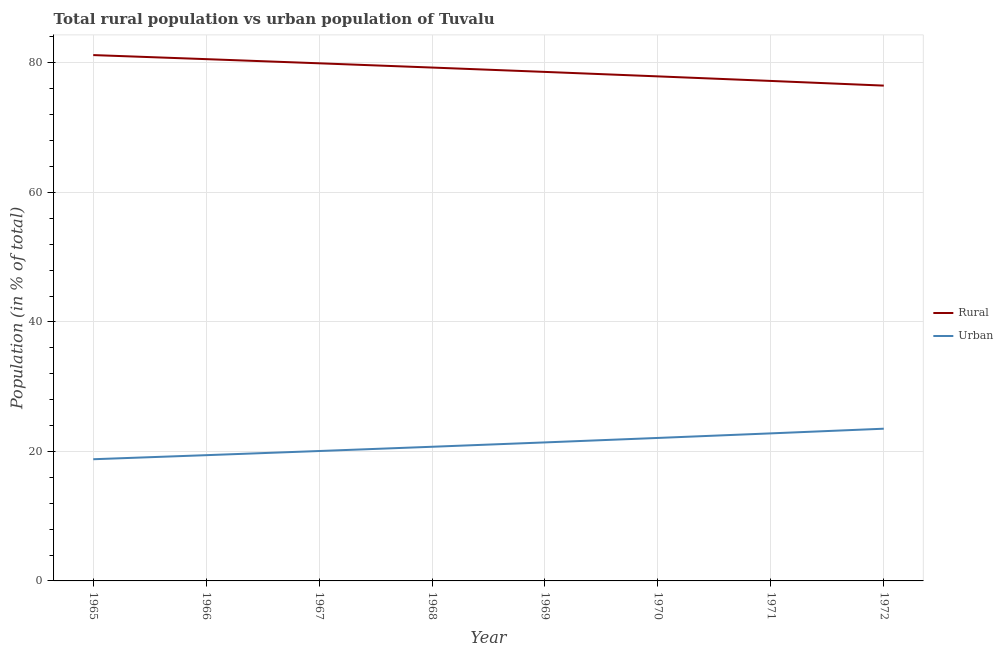What is the urban population in 1970?
Your response must be concise. 22.08. Across all years, what is the maximum urban population?
Ensure brevity in your answer.  23.51. Across all years, what is the minimum rural population?
Ensure brevity in your answer.  76.49. In which year was the rural population maximum?
Your answer should be very brief. 1965. In which year was the rural population minimum?
Ensure brevity in your answer.  1972. What is the total rural population in the graph?
Your answer should be compact. 631.24. What is the difference between the urban population in 1968 and that in 1971?
Your answer should be compact. -2.07. What is the difference between the urban population in 1965 and the rural population in 1968?
Offer a very short reply. -60.49. What is the average urban population per year?
Offer a very short reply. 21.09. In the year 1967, what is the difference between the urban population and rural population?
Give a very brief answer. -59.88. In how many years, is the rural population greater than 8 %?
Make the answer very short. 8. What is the ratio of the urban population in 1967 to that in 1969?
Ensure brevity in your answer.  0.94. Is the rural population in 1965 less than that in 1971?
Your answer should be very brief. No. What is the difference between the highest and the second highest rural population?
Offer a terse response. 0.63. What is the difference between the highest and the lowest urban population?
Give a very brief answer. 4.71. How many lines are there?
Offer a terse response. 2. What is the difference between two consecutive major ticks on the Y-axis?
Offer a very short reply. 20. Are the values on the major ticks of Y-axis written in scientific E-notation?
Your answer should be very brief. No. Does the graph contain grids?
Provide a short and direct response. Yes. Where does the legend appear in the graph?
Give a very brief answer. Center right. How are the legend labels stacked?
Keep it short and to the point. Vertical. What is the title of the graph?
Ensure brevity in your answer.  Total rural population vs urban population of Tuvalu. Does "Under-5(female)" appear as one of the legend labels in the graph?
Make the answer very short. No. What is the label or title of the X-axis?
Your response must be concise. Year. What is the label or title of the Y-axis?
Your answer should be very brief. Population (in % of total). What is the Population (in % of total) of Rural in 1965?
Make the answer very short. 81.21. What is the Population (in % of total) in Urban in 1965?
Ensure brevity in your answer.  18.79. What is the Population (in % of total) of Rural in 1966?
Your answer should be very brief. 80.58. What is the Population (in % of total) in Urban in 1966?
Your answer should be compact. 19.42. What is the Population (in % of total) of Rural in 1967?
Make the answer very short. 79.94. What is the Population (in % of total) in Urban in 1967?
Your answer should be very brief. 20.06. What is the Population (in % of total) in Rural in 1968?
Keep it short and to the point. 79.28. What is the Population (in % of total) in Urban in 1968?
Your response must be concise. 20.72. What is the Population (in % of total) in Rural in 1969?
Your answer should be compact. 78.61. What is the Population (in % of total) of Urban in 1969?
Keep it short and to the point. 21.39. What is the Population (in % of total) in Rural in 1970?
Offer a very short reply. 77.92. What is the Population (in % of total) in Urban in 1970?
Provide a succinct answer. 22.08. What is the Population (in % of total) of Rural in 1971?
Provide a succinct answer. 77.21. What is the Population (in % of total) of Urban in 1971?
Offer a very short reply. 22.79. What is the Population (in % of total) in Rural in 1972?
Make the answer very short. 76.49. What is the Population (in % of total) of Urban in 1972?
Provide a short and direct response. 23.51. Across all years, what is the maximum Population (in % of total) in Rural?
Offer a terse response. 81.21. Across all years, what is the maximum Population (in % of total) of Urban?
Your response must be concise. 23.51. Across all years, what is the minimum Population (in % of total) of Rural?
Give a very brief answer. 76.49. Across all years, what is the minimum Population (in % of total) in Urban?
Ensure brevity in your answer.  18.79. What is the total Population (in % of total) of Rural in the graph?
Make the answer very short. 631.24. What is the total Population (in % of total) in Urban in the graph?
Your answer should be compact. 168.76. What is the difference between the Population (in % of total) in Rural in 1965 and that in 1966?
Make the answer very short. 0.63. What is the difference between the Population (in % of total) of Urban in 1965 and that in 1966?
Keep it short and to the point. -0.63. What is the difference between the Population (in % of total) in Rural in 1965 and that in 1967?
Your answer should be compact. 1.27. What is the difference between the Population (in % of total) of Urban in 1965 and that in 1967?
Make the answer very short. -1.27. What is the difference between the Population (in % of total) in Rural in 1965 and that in 1968?
Provide a succinct answer. 1.93. What is the difference between the Population (in % of total) in Urban in 1965 and that in 1968?
Your answer should be very brief. -1.93. What is the difference between the Population (in % of total) of Rural in 1965 and that in 1969?
Provide a short and direct response. 2.6. What is the difference between the Population (in % of total) in Urban in 1965 and that in 1969?
Your answer should be compact. -2.6. What is the difference between the Population (in % of total) of Rural in 1965 and that in 1970?
Offer a very short reply. 3.29. What is the difference between the Population (in % of total) in Urban in 1965 and that in 1970?
Make the answer very short. -3.29. What is the difference between the Population (in % of total) of Rural in 1965 and that in 1971?
Your answer should be compact. 3.99. What is the difference between the Population (in % of total) in Urban in 1965 and that in 1971?
Offer a very short reply. -3.99. What is the difference between the Population (in % of total) in Rural in 1965 and that in 1972?
Offer a very short reply. 4.71. What is the difference between the Population (in % of total) in Urban in 1965 and that in 1972?
Your answer should be compact. -4.71. What is the difference between the Population (in % of total) of Rural in 1966 and that in 1967?
Your response must be concise. 0.64. What is the difference between the Population (in % of total) in Urban in 1966 and that in 1967?
Provide a succinct answer. -0.64. What is the difference between the Population (in % of total) of Rural in 1966 and that in 1968?
Your answer should be very brief. 1.3. What is the difference between the Population (in % of total) in Urban in 1966 and that in 1968?
Your response must be concise. -1.3. What is the difference between the Population (in % of total) of Rural in 1966 and that in 1969?
Make the answer very short. 1.97. What is the difference between the Population (in % of total) of Urban in 1966 and that in 1969?
Your answer should be compact. -1.97. What is the difference between the Population (in % of total) in Rural in 1966 and that in 1970?
Make the answer very short. 2.66. What is the difference between the Population (in % of total) of Urban in 1966 and that in 1970?
Your answer should be very brief. -2.66. What is the difference between the Population (in % of total) of Rural in 1966 and that in 1971?
Offer a terse response. 3.37. What is the difference between the Population (in % of total) in Urban in 1966 and that in 1971?
Ensure brevity in your answer.  -3.37. What is the difference between the Population (in % of total) in Rural in 1966 and that in 1972?
Offer a terse response. 4.09. What is the difference between the Population (in % of total) in Urban in 1966 and that in 1972?
Provide a short and direct response. -4.09. What is the difference between the Population (in % of total) in Rural in 1967 and that in 1968?
Your answer should be very brief. 0.66. What is the difference between the Population (in % of total) of Urban in 1967 and that in 1968?
Your response must be concise. -0.66. What is the difference between the Population (in % of total) of Rural in 1967 and that in 1969?
Keep it short and to the point. 1.33. What is the difference between the Population (in % of total) of Urban in 1967 and that in 1969?
Give a very brief answer. -1.33. What is the difference between the Population (in % of total) in Rural in 1967 and that in 1970?
Your response must be concise. 2.02. What is the difference between the Population (in % of total) in Urban in 1967 and that in 1970?
Provide a short and direct response. -2.02. What is the difference between the Population (in % of total) of Rural in 1967 and that in 1971?
Provide a short and direct response. 2.73. What is the difference between the Population (in % of total) of Urban in 1967 and that in 1971?
Your answer should be compact. -2.73. What is the difference between the Population (in % of total) of Rural in 1967 and that in 1972?
Offer a very short reply. 3.45. What is the difference between the Population (in % of total) in Urban in 1967 and that in 1972?
Make the answer very short. -3.45. What is the difference between the Population (in % of total) of Rural in 1968 and that in 1969?
Ensure brevity in your answer.  0.67. What is the difference between the Population (in % of total) in Urban in 1968 and that in 1969?
Provide a succinct answer. -0.67. What is the difference between the Population (in % of total) in Rural in 1968 and that in 1970?
Your response must be concise. 1.36. What is the difference between the Population (in % of total) in Urban in 1968 and that in 1970?
Offer a terse response. -1.36. What is the difference between the Population (in % of total) in Rural in 1968 and that in 1971?
Offer a very short reply. 2.07. What is the difference between the Population (in % of total) of Urban in 1968 and that in 1971?
Provide a short and direct response. -2.07. What is the difference between the Population (in % of total) of Rural in 1968 and that in 1972?
Your response must be concise. 2.79. What is the difference between the Population (in % of total) in Urban in 1968 and that in 1972?
Your response must be concise. -2.79. What is the difference between the Population (in % of total) of Rural in 1969 and that in 1970?
Give a very brief answer. 0.69. What is the difference between the Population (in % of total) in Urban in 1969 and that in 1970?
Give a very brief answer. -0.69. What is the difference between the Population (in % of total) in Rural in 1969 and that in 1971?
Your answer should be very brief. 1.39. What is the difference between the Population (in % of total) of Urban in 1969 and that in 1971?
Your answer should be compact. -1.39. What is the difference between the Population (in % of total) of Rural in 1969 and that in 1972?
Provide a short and direct response. 2.12. What is the difference between the Population (in % of total) of Urban in 1969 and that in 1972?
Ensure brevity in your answer.  -2.12. What is the difference between the Population (in % of total) in Rural in 1970 and that in 1971?
Provide a short and direct response. 0.7. What is the difference between the Population (in % of total) in Urban in 1970 and that in 1971?
Provide a succinct answer. -0.7. What is the difference between the Population (in % of total) in Rural in 1970 and that in 1972?
Keep it short and to the point. 1.43. What is the difference between the Population (in % of total) of Urban in 1970 and that in 1972?
Offer a very short reply. -1.43. What is the difference between the Population (in % of total) in Rural in 1971 and that in 1972?
Ensure brevity in your answer.  0.72. What is the difference between the Population (in % of total) of Urban in 1971 and that in 1972?
Keep it short and to the point. -0.72. What is the difference between the Population (in % of total) of Rural in 1965 and the Population (in % of total) of Urban in 1966?
Keep it short and to the point. 61.79. What is the difference between the Population (in % of total) in Rural in 1965 and the Population (in % of total) in Urban in 1967?
Your response must be concise. 61.15. What is the difference between the Population (in % of total) in Rural in 1965 and the Population (in % of total) in Urban in 1968?
Your answer should be compact. 60.49. What is the difference between the Population (in % of total) in Rural in 1965 and the Population (in % of total) in Urban in 1969?
Offer a very short reply. 59.81. What is the difference between the Population (in % of total) of Rural in 1965 and the Population (in % of total) of Urban in 1970?
Provide a succinct answer. 59.13. What is the difference between the Population (in % of total) of Rural in 1965 and the Population (in % of total) of Urban in 1971?
Your answer should be compact. 58.42. What is the difference between the Population (in % of total) of Rural in 1965 and the Population (in % of total) of Urban in 1972?
Your answer should be compact. 57.7. What is the difference between the Population (in % of total) in Rural in 1966 and the Population (in % of total) in Urban in 1967?
Your answer should be very brief. 60.52. What is the difference between the Population (in % of total) of Rural in 1966 and the Population (in % of total) of Urban in 1968?
Make the answer very short. 59.86. What is the difference between the Population (in % of total) in Rural in 1966 and the Population (in % of total) in Urban in 1969?
Your answer should be compact. 59.19. What is the difference between the Population (in % of total) in Rural in 1966 and the Population (in % of total) in Urban in 1970?
Give a very brief answer. 58.5. What is the difference between the Population (in % of total) of Rural in 1966 and the Population (in % of total) of Urban in 1971?
Ensure brevity in your answer.  57.8. What is the difference between the Population (in % of total) in Rural in 1966 and the Population (in % of total) in Urban in 1972?
Your answer should be compact. 57.07. What is the difference between the Population (in % of total) of Rural in 1967 and the Population (in % of total) of Urban in 1968?
Offer a very short reply. 59.22. What is the difference between the Population (in % of total) in Rural in 1967 and the Population (in % of total) in Urban in 1969?
Offer a terse response. 58.55. What is the difference between the Population (in % of total) of Rural in 1967 and the Population (in % of total) of Urban in 1970?
Offer a very short reply. 57.86. What is the difference between the Population (in % of total) in Rural in 1967 and the Population (in % of total) in Urban in 1971?
Your response must be concise. 57.15. What is the difference between the Population (in % of total) in Rural in 1967 and the Population (in % of total) in Urban in 1972?
Provide a short and direct response. 56.43. What is the difference between the Population (in % of total) in Rural in 1968 and the Population (in % of total) in Urban in 1969?
Your answer should be compact. 57.89. What is the difference between the Population (in % of total) in Rural in 1968 and the Population (in % of total) in Urban in 1970?
Make the answer very short. 57.2. What is the difference between the Population (in % of total) of Rural in 1968 and the Population (in % of total) of Urban in 1971?
Ensure brevity in your answer.  56.49. What is the difference between the Population (in % of total) in Rural in 1968 and the Population (in % of total) in Urban in 1972?
Offer a very short reply. 55.77. What is the difference between the Population (in % of total) in Rural in 1969 and the Population (in % of total) in Urban in 1970?
Provide a short and direct response. 56.53. What is the difference between the Population (in % of total) of Rural in 1969 and the Population (in % of total) of Urban in 1971?
Provide a succinct answer. 55.82. What is the difference between the Population (in % of total) of Rural in 1969 and the Population (in % of total) of Urban in 1972?
Your answer should be compact. 55.1. What is the difference between the Population (in % of total) of Rural in 1970 and the Population (in % of total) of Urban in 1971?
Provide a short and direct response. 55.13. What is the difference between the Population (in % of total) in Rural in 1970 and the Population (in % of total) in Urban in 1972?
Your answer should be very brief. 54.41. What is the difference between the Population (in % of total) in Rural in 1971 and the Population (in % of total) in Urban in 1972?
Offer a terse response. 53.71. What is the average Population (in % of total) of Rural per year?
Offer a very short reply. 78.91. What is the average Population (in % of total) in Urban per year?
Give a very brief answer. 21.09. In the year 1965, what is the difference between the Population (in % of total) of Rural and Population (in % of total) of Urban?
Offer a very short reply. 62.41. In the year 1966, what is the difference between the Population (in % of total) of Rural and Population (in % of total) of Urban?
Provide a succinct answer. 61.16. In the year 1967, what is the difference between the Population (in % of total) in Rural and Population (in % of total) in Urban?
Provide a short and direct response. 59.88. In the year 1968, what is the difference between the Population (in % of total) of Rural and Population (in % of total) of Urban?
Ensure brevity in your answer.  58.56. In the year 1969, what is the difference between the Population (in % of total) in Rural and Population (in % of total) in Urban?
Make the answer very short. 57.22. In the year 1970, what is the difference between the Population (in % of total) in Rural and Population (in % of total) in Urban?
Keep it short and to the point. 55.84. In the year 1971, what is the difference between the Population (in % of total) of Rural and Population (in % of total) of Urban?
Your response must be concise. 54.43. In the year 1972, what is the difference between the Population (in % of total) in Rural and Population (in % of total) in Urban?
Make the answer very short. 52.99. What is the ratio of the Population (in % of total) in Urban in 1965 to that in 1966?
Your response must be concise. 0.97. What is the ratio of the Population (in % of total) of Rural in 1965 to that in 1967?
Ensure brevity in your answer.  1.02. What is the ratio of the Population (in % of total) of Urban in 1965 to that in 1967?
Provide a short and direct response. 0.94. What is the ratio of the Population (in % of total) in Rural in 1965 to that in 1968?
Your answer should be very brief. 1.02. What is the ratio of the Population (in % of total) in Urban in 1965 to that in 1968?
Keep it short and to the point. 0.91. What is the ratio of the Population (in % of total) in Rural in 1965 to that in 1969?
Provide a short and direct response. 1.03. What is the ratio of the Population (in % of total) of Urban in 1965 to that in 1969?
Ensure brevity in your answer.  0.88. What is the ratio of the Population (in % of total) in Rural in 1965 to that in 1970?
Make the answer very short. 1.04. What is the ratio of the Population (in % of total) in Urban in 1965 to that in 1970?
Provide a short and direct response. 0.85. What is the ratio of the Population (in % of total) of Rural in 1965 to that in 1971?
Provide a short and direct response. 1.05. What is the ratio of the Population (in % of total) in Urban in 1965 to that in 1971?
Offer a terse response. 0.82. What is the ratio of the Population (in % of total) in Rural in 1965 to that in 1972?
Ensure brevity in your answer.  1.06. What is the ratio of the Population (in % of total) in Urban in 1965 to that in 1972?
Provide a short and direct response. 0.8. What is the ratio of the Population (in % of total) in Urban in 1966 to that in 1967?
Your response must be concise. 0.97. What is the ratio of the Population (in % of total) of Rural in 1966 to that in 1968?
Ensure brevity in your answer.  1.02. What is the ratio of the Population (in % of total) of Urban in 1966 to that in 1968?
Offer a terse response. 0.94. What is the ratio of the Population (in % of total) of Rural in 1966 to that in 1969?
Your response must be concise. 1.03. What is the ratio of the Population (in % of total) of Urban in 1966 to that in 1969?
Ensure brevity in your answer.  0.91. What is the ratio of the Population (in % of total) in Rural in 1966 to that in 1970?
Give a very brief answer. 1.03. What is the ratio of the Population (in % of total) of Urban in 1966 to that in 1970?
Offer a very short reply. 0.88. What is the ratio of the Population (in % of total) in Rural in 1966 to that in 1971?
Provide a succinct answer. 1.04. What is the ratio of the Population (in % of total) in Urban in 1966 to that in 1971?
Your answer should be compact. 0.85. What is the ratio of the Population (in % of total) of Rural in 1966 to that in 1972?
Your response must be concise. 1.05. What is the ratio of the Population (in % of total) of Urban in 1966 to that in 1972?
Keep it short and to the point. 0.83. What is the ratio of the Population (in % of total) of Rural in 1967 to that in 1968?
Your answer should be very brief. 1.01. What is the ratio of the Population (in % of total) in Urban in 1967 to that in 1968?
Make the answer very short. 0.97. What is the ratio of the Population (in % of total) in Rural in 1967 to that in 1969?
Offer a very short reply. 1.02. What is the ratio of the Population (in % of total) of Urban in 1967 to that in 1969?
Ensure brevity in your answer.  0.94. What is the ratio of the Population (in % of total) of Rural in 1967 to that in 1970?
Offer a terse response. 1.03. What is the ratio of the Population (in % of total) in Urban in 1967 to that in 1970?
Provide a short and direct response. 0.91. What is the ratio of the Population (in % of total) of Rural in 1967 to that in 1971?
Give a very brief answer. 1.04. What is the ratio of the Population (in % of total) in Urban in 1967 to that in 1971?
Keep it short and to the point. 0.88. What is the ratio of the Population (in % of total) of Rural in 1967 to that in 1972?
Offer a very short reply. 1.04. What is the ratio of the Population (in % of total) of Urban in 1967 to that in 1972?
Your answer should be very brief. 0.85. What is the ratio of the Population (in % of total) of Rural in 1968 to that in 1969?
Your answer should be compact. 1.01. What is the ratio of the Population (in % of total) of Urban in 1968 to that in 1969?
Offer a terse response. 0.97. What is the ratio of the Population (in % of total) of Rural in 1968 to that in 1970?
Give a very brief answer. 1.02. What is the ratio of the Population (in % of total) of Urban in 1968 to that in 1970?
Offer a very short reply. 0.94. What is the ratio of the Population (in % of total) of Rural in 1968 to that in 1971?
Your response must be concise. 1.03. What is the ratio of the Population (in % of total) in Urban in 1968 to that in 1971?
Offer a terse response. 0.91. What is the ratio of the Population (in % of total) in Rural in 1968 to that in 1972?
Give a very brief answer. 1.04. What is the ratio of the Population (in % of total) in Urban in 1968 to that in 1972?
Your answer should be very brief. 0.88. What is the ratio of the Population (in % of total) of Rural in 1969 to that in 1970?
Your response must be concise. 1.01. What is the ratio of the Population (in % of total) of Urban in 1969 to that in 1970?
Give a very brief answer. 0.97. What is the ratio of the Population (in % of total) in Rural in 1969 to that in 1971?
Your response must be concise. 1.02. What is the ratio of the Population (in % of total) in Urban in 1969 to that in 1971?
Make the answer very short. 0.94. What is the ratio of the Population (in % of total) of Rural in 1969 to that in 1972?
Offer a very short reply. 1.03. What is the ratio of the Population (in % of total) in Urban in 1969 to that in 1972?
Give a very brief answer. 0.91. What is the ratio of the Population (in % of total) in Rural in 1970 to that in 1971?
Make the answer very short. 1.01. What is the ratio of the Population (in % of total) in Urban in 1970 to that in 1971?
Make the answer very short. 0.97. What is the ratio of the Population (in % of total) of Rural in 1970 to that in 1972?
Keep it short and to the point. 1.02. What is the ratio of the Population (in % of total) of Urban in 1970 to that in 1972?
Provide a succinct answer. 0.94. What is the ratio of the Population (in % of total) of Rural in 1971 to that in 1972?
Your answer should be compact. 1.01. What is the ratio of the Population (in % of total) of Urban in 1971 to that in 1972?
Offer a terse response. 0.97. What is the difference between the highest and the second highest Population (in % of total) in Rural?
Ensure brevity in your answer.  0.63. What is the difference between the highest and the second highest Population (in % of total) of Urban?
Provide a succinct answer. 0.72. What is the difference between the highest and the lowest Population (in % of total) in Rural?
Your answer should be very brief. 4.71. What is the difference between the highest and the lowest Population (in % of total) in Urban?
Your response must be concise. 4.71. 